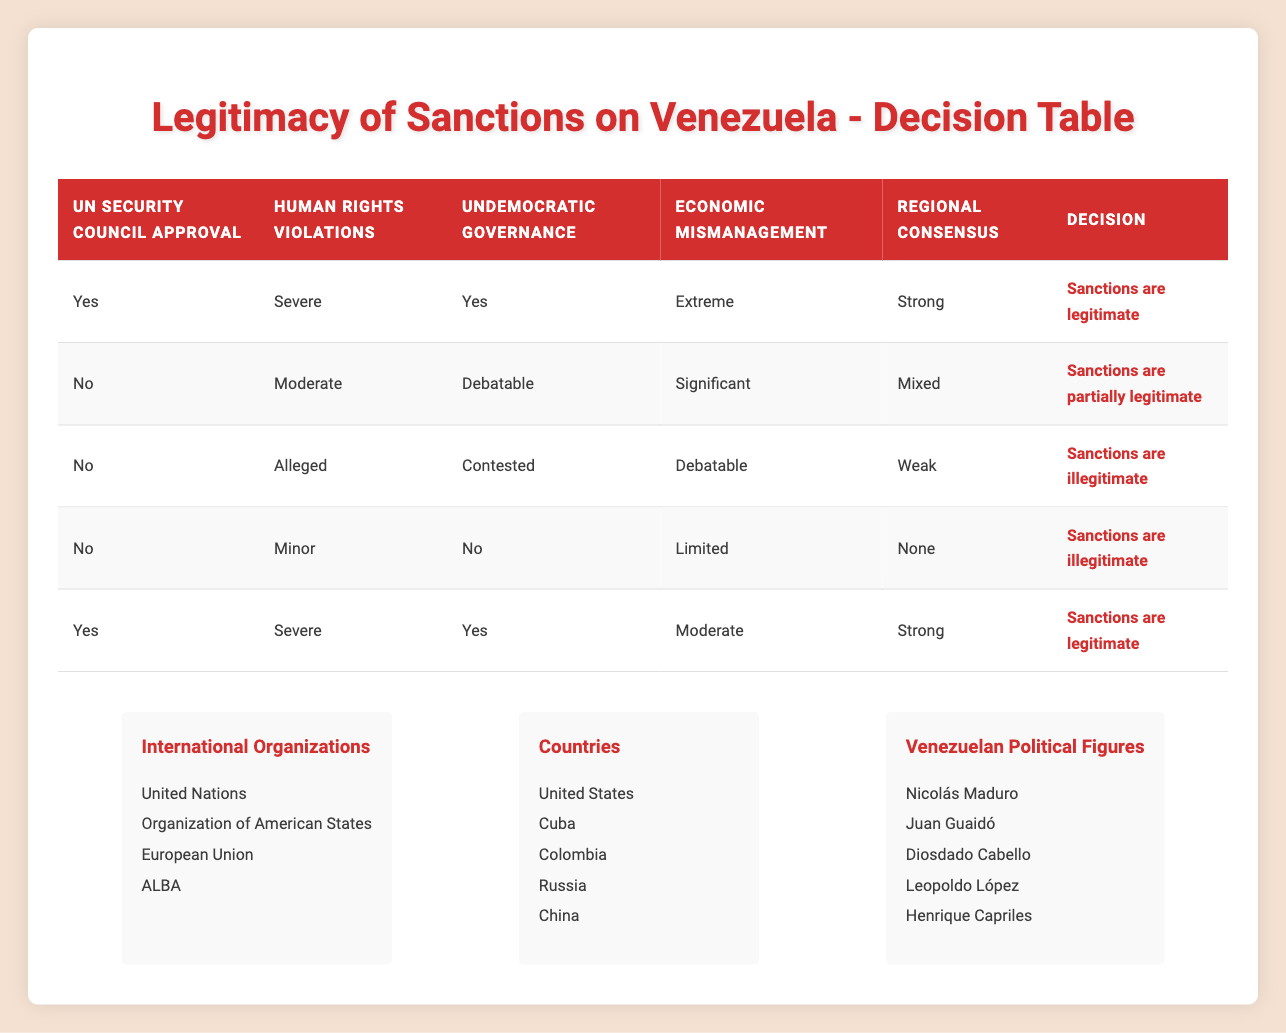What is the decision when there is UN Security Council approval and severe human rights violations? According to the rule in the table, when there is UN Security Council approval (Yes) and severe human rights violations (Severe), the decision is that "Sanctions are legitimate."
Answer: Sanctions are legitimate How many rules in the table indicate that sanctions are illegitimate? There are three rules in the table where sanctions are decided to be illegitimate. They are based on the criteria showing either "No" for UN Security Council approval or conditions indicating minor human rights violations, undemocratic governance, and more.
Answer: 3 Is there a rule that supports the decision of "Sanctions are partially legitimate"? Yes, there is one rule where sanctions are deemed partially legitimate: it states that there is no UN Security Council approval, with moderate human rights violations and debatable undemocratic governance.
Answer: Yes What would be the decision if there is strong regional consensus but economic mismanagement is significant? The decision would be "Sanctions are partially legitimate." According to the second rule, there is no UN Security Council approval, significant economic mismanagement, and mixed regional consensus, leading to partial legitimacy.
Answer: Sanctions are partially legitimate If there are severe human rights violations, undemocratic governance, and moderate economic mismanagement, what is the decision given that there is UN Security Council approval? The decision would be "Sanctions are legitimate." The rule states if there's UN Security Council approval, severe human rights violations, yes to undemocratic governance, and moderate economic mismanagement, it confirms legitimacy.
Answer: Sanctions are legitimate Are there any instances where sanctions are deemed legitimate without severe human rights violations? No, all instances of legitimacy are linked to severe human rights violations. Any other category of human rights violations leads to partial or illegitimate decisions.
Answer: No What is the difference between the economic mismanagement level in the legitimate and partially legitimate sanctions? In the legitimate sanctions, the economic mismanagement levels are described as either moderate or extreme, whereas, for partially legitimate sanctions, it is indicated as significant. The differences are therefore between moderate/extreme and significant.
Answer: Moderate/Extreme vs. Significant Which decision corresponds to the lowest severity of human rights violations? The decision corresponding to the lowest severity of human rights violations is "Sanctions are illegitimate," specifically in the case where human rights violations are noted as minor and the governance is stated as no.
Answer: Sanctions are illegitimate If we consider the decisions collectively, how many rules support the legitimacy of sanctions versus illegitimacy? There are two rules supporting the legitimacy of sanctions and three rules indicating illegitimacy. Thus, legitimacy is less supported than illegitimacy. This demonstrates a trend towards condemning the sanctions.
Answer: 2 legitimate, 3 illegitimate 